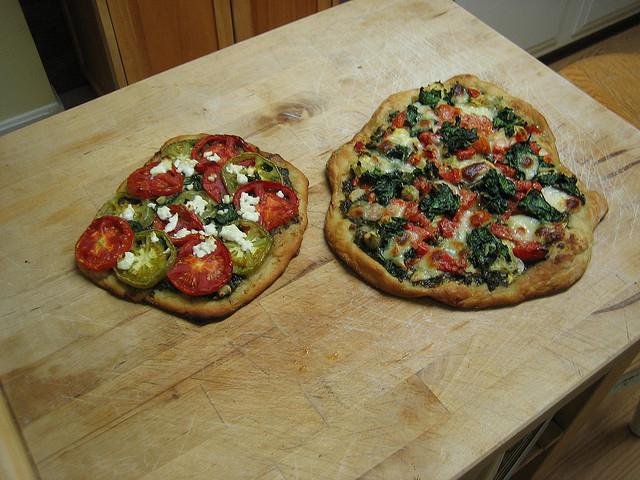Are the pizzas round?
Write a very short answer. No. How many different types of tomatoes are on the left pizza?
Short answer required. 2. What's covering most of the pizza?
Answer briefly. Vegetables. What type of food is this?
Write a very short answer. Pizza. Which one looks more healthy?
Give a very brief answer. Left. How many slices of tomatoes do you see?
Be succinct. 7. 